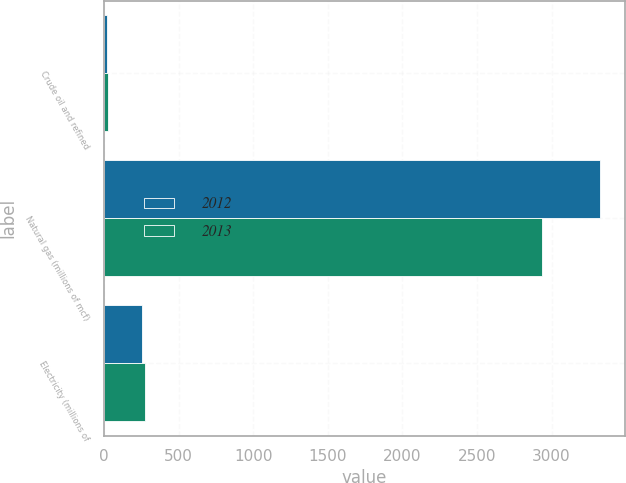Convert chart. <chart><loc_0><loc_0><loc_500><loc_500><stacked_bar_chart><ecel><fcel>Crude oil and refined<fcel>Natural gas (millions of mcf)<fcel>Electricity (millions of<nl><fcel>2012<fcel>19<fcel>3325<fcel>258<nl><fcel>2013<fcel>26<fcel>2938<fcel>278<nl></chart> 